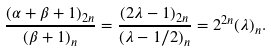<formula> <loc_0><loc_0><loc_500><loc_500>\frac { ( \alpha + \beta + 1 ) _ { 2 n } } { ( \beta + 1 ) _ { n } } = \frac { ( 2 \lambda - 1 ) _ { 2 n } } { ( \lambda - 1 / 2 ) _ { n } } = 2 ^ { 2 n } ( \lambda ) _ { n } .</formula> 